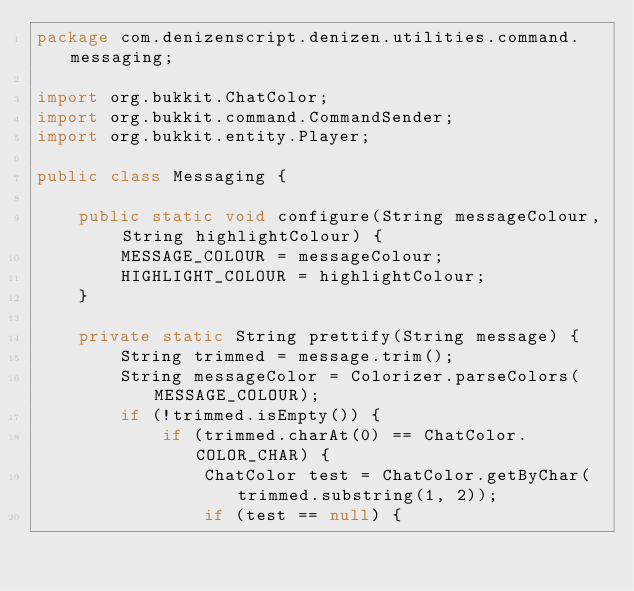Convert code to text. <code><loc_0><loc_0><loc_500><loc_500><_Java_>package com.denizenscript.denizen.utilities.command.messaging;

import org.bukkit.ChatColor;
import org.bukkit.command.CommandSender;
import org.bukkit.entity.Player;

public class Messaging {

    public static void configure(String messageColour, String highlightColour) {
        MESSAGE_COLOUR = messageColour;
        HIGHLIGHT_COLOUR = highlightColour;
    }

    private static String prettify(String message) {
        String trimmed = message.trim();
        String messageColor = Colorizer.parseColors(MESSAGE_COLOUR);
        if (!trimmed.isEmpty()) {
            if (trimmed.charAt(0) == ChatColor.COLOR_CHAR) {
                ChatColor test = ChatColor.getByChar(trimmed.substring(1, 2));
                if (test == null) {</code> 